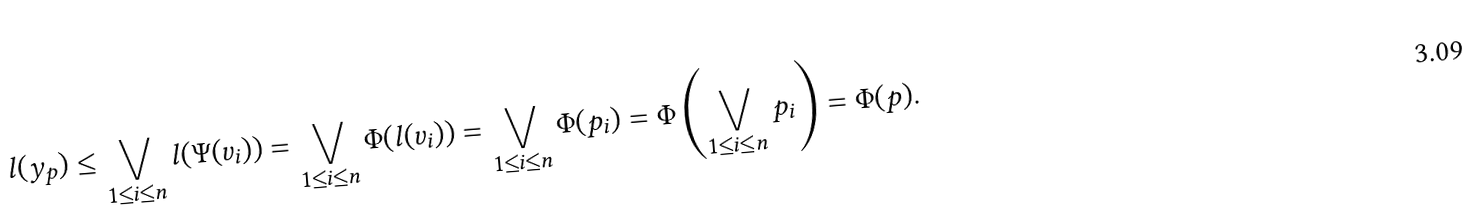<formula> <loc_0><loc_0><loc_500><loc_500>l ( y _ { p } ) \leq \bigvee _ { 1 \leq i \leq n } l ( \Psi ( v _ { i } ) ) = \bigvee _ { 1 \leq i \leq n } \Phi ( l ( v _ { i } ) ) = \bigvee _ { 1 \leq i \leq n } \Phi ( p _ { i } ) = \Phi \left ( \bigvee _ { 1 \leq i \leq n } p _ { i } \right ) = \Phi ( p ) .</formula> 